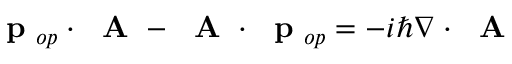<formula> <loc_0><loc_0><loc_500><loc_500>p _ { o p } \cdot A - A \cdot p _ { o p } = - i \hbar { \nabla } \cdot A</formula> 